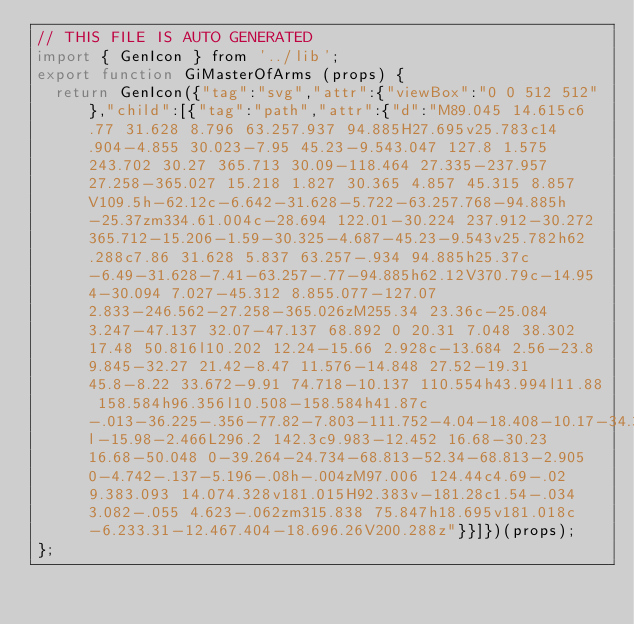<code> <loc_0><loc_0><loc_500><loc_500><_JavaScript_>// THIS FILE IS AUTO GENERATED
import { GenIcon } from '../lib';
export function GiMasterOfArms (props) {
  return GenIcon({"tag":"svg","attr":{"viewBox":"0 0 512 512"},"child":[{"tag":"path","attr":{"d":"M89.045 14.615c6.77 31.628 8.796 63.257.937 94.885H27.695v25.783c14.904-4.855 30.023-7.95 45.23-9.543.047 127.8 1.575 243.702 30.27 365.713 30.09-118.464 27.335-237.957 27.258-365.027 15.218 1.827 30.365 4.857 45.315 8.857V109.5h-62.12c-6.642-31.628-5.722-63.257.768-94.885h-25.37zm334.61.004c-28.694 122.01-30.224 237.912-30.272 365.712-15.206-1.59-30.325-4.687-45.23-9.543v25.782h62.288c7.86 31.628 5.837 63.257-.934 94.885h25.37c-6.49-31.628-7.41-63.257-.77-94.885h62.12V370.79c-14.95 4-30.094 7.027-45.312 8.855.077-127.07 2.833-246.562-27.258-365.026zM255.34 23.36c-25.084 3.247-47.137 32.07-47.137 68.892 0 20.31 7.048 38.302 17.48 50.816l10.202 12.24-15.66 2.928c-13.684 2.56-23.8 9.845-32.27 21.42-8.47 11.576-14.848 27.52-19.31 45.8-8.22 33.672-9.91 74.718-10.137 110.554h43.994l11.88 158.584h96.356l10.508-158.584h41.87c-.013-36.225-.356-77.82-7.803-111.752-4.04-18.408-10.17-34.354-18.762-45.822-8.592-11.47-19.2-18.7-34.482-21.057l-15.98-2.466L296.2 142.3c9.983-12.452 16.68-30.23 16.68-50.048 0-39.264-24.734-68.813-52.34-68.813-2.905 0-4.742-.137-5.196-.08h-.004zM97.006 124.44c4.69-.02 9.383.093 14.074.328v181.015H92.383v-181.28c1.54-.034 3.082-.055 4.623-.062zm315.838 75.847h18.695v181.018c-6.233.31-12.467.404-18.696.26V200.288z"}}]})(props);
};
</code> 